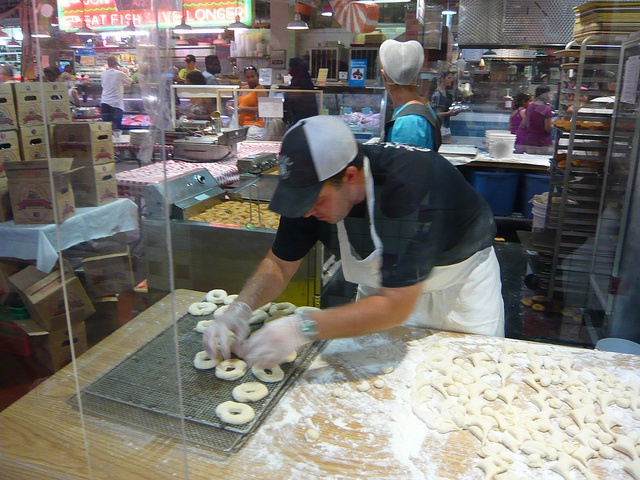Describe the objects in this image and their specific colors. I can see dining table in navy, ivory, gray, and darkgray tones, people in navy, black, darkgray, and gray tones, people in navy, gray, darkgray, lightgray, and teal tones, donut in navy, black, tan, gray, and olive tones, and people in navy, gray, and darkgray tones in this image. 